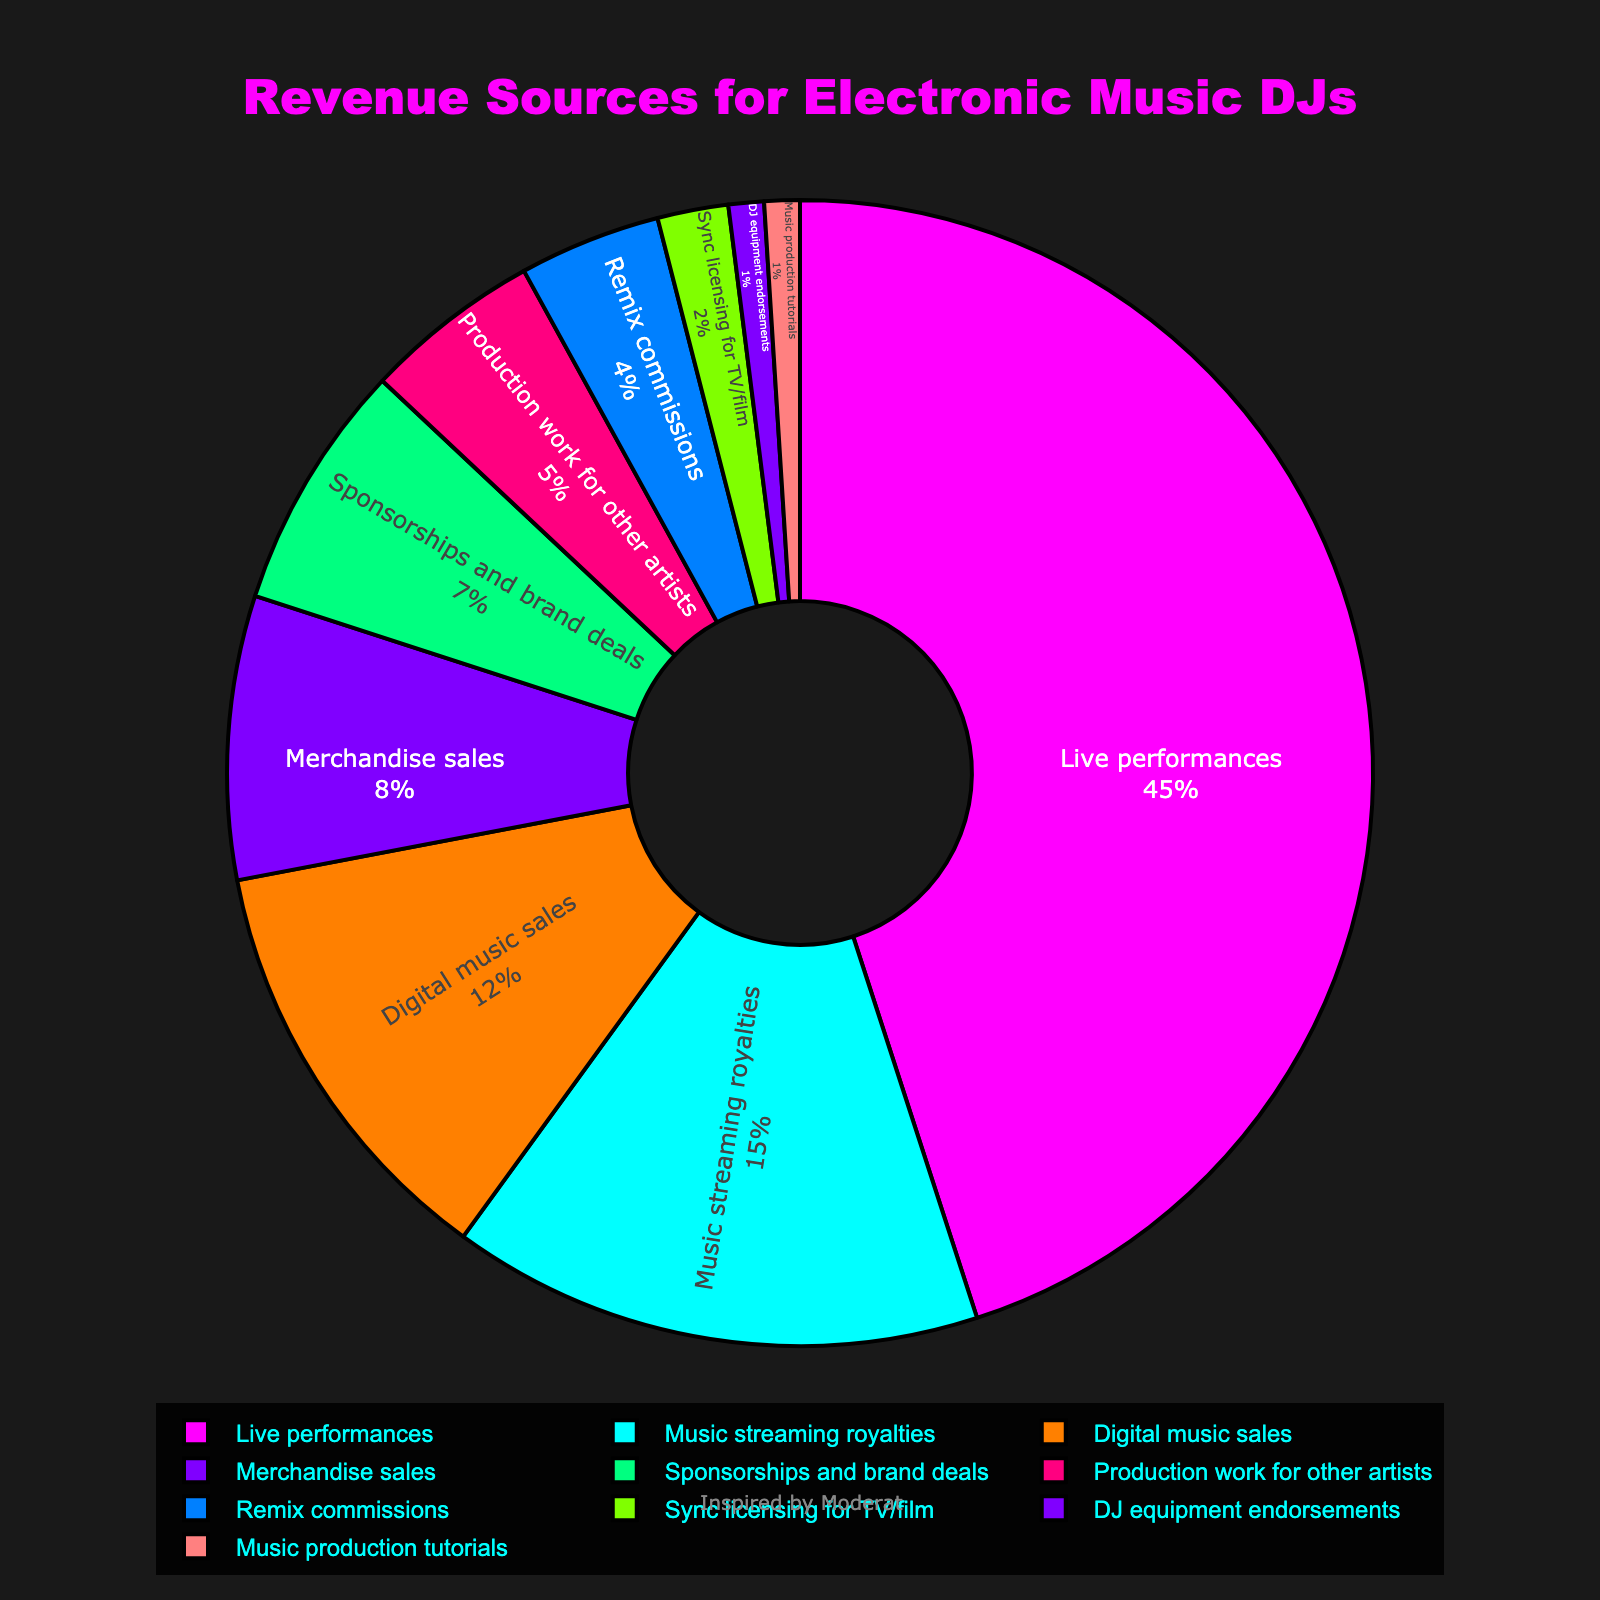What is the largest revenue source for electronic music DJs according to the chart? The largest segment of the pie chart represents live performances, which takes up the biggest portion.
Answer: Live performances Which revenue source contributes the least to the total revenue for electronic music DJs? The smallest segment of the pie chart is for DJ equipment endorsements and music production tutorials, both at the bottom.
Answer: DJ equipment endorsements and Music production tutorials How many percentage points more do live performances contribute compared to music streaming royalties? Live performances contribute 45%, and music streaming royalties contribute 15%. The difference is 45% - 15% = 30%.
Answer: 30 percentage points What is the combined percentage for digital music sales and merchandise sales? Digital music sales contribute 12%, and merchandise sales contribute 8%. The combined percentage is 12% + 8% = 20%.
Answer: 20% Which revenue source makes up 15% of the total revenue? The segment labeled "Music streaming royalties" indicates a 15% contribution to the total revenue.
Answer: Music streaming royalties Compare the revenue from production work for other artists and remix commissions. Which one is higher and by how much? Production work for other artists contributes 5%, and remix commissions contribute 4%. The revenue from production work for other artists is 1% higher.
Answer: Production work for other artists by 1% Which revenue sources collectively amount to the same percentage contribution as live performances? Live performances contribute 45%. Combining music streaming royalties (15%), digital music sales (12%), merchandise sales (8%), sponsorships and brand deals (7%), and production work for other artists (5%) equals 45%.
Answer: Music streaming royalties, digital music sales, merchandise sales, sponsorships and brand deals, and production work for other artists How does the visual representation of the slice sizes compare between sponsorships and brand deals and sync licensing for TV/film? The sponsorships and brand deals segment is visually larger than the sync licensing for TV/film segment in the pie chart, indicating a higher percentage contribution.
Answer: Sponsorships and brand deals are larger If you were to combine the percentages of remix commissions and sync licensing for TV/film, would it be greater or less than merchandise sales? Remix commissions are 4%, and sync licensing for TV/film is 2%. Combined, they make 4% + 2% = 6%, which is less than merchandise sales at 8%.
Answer: Less Which sections of the pie chart are located next to the live performances segment? The sections adjacent to the live performances segment are likely music streaming royalties and digital music sales based on the standard clockwise or counter-clockwise arrangement.
Answer: Music streaming royalties and Digital music sales 